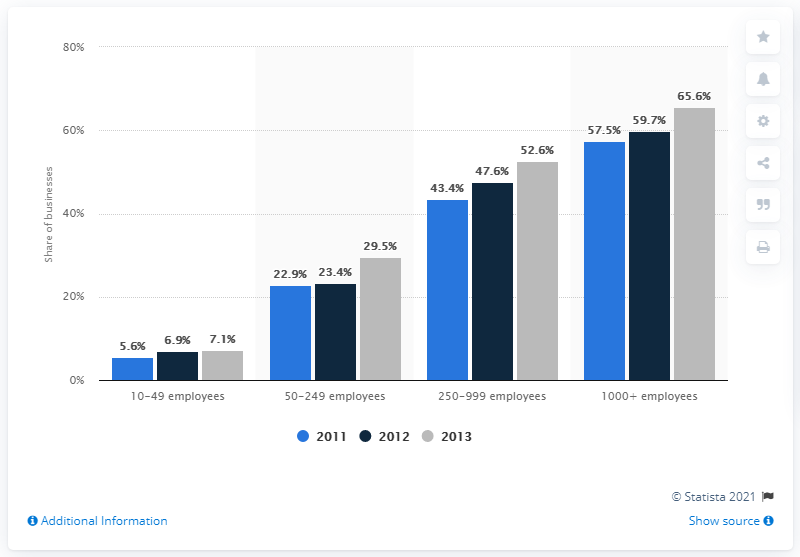Indicate a few pertinent items in this graphic. In 2013, the color grey is associated with a particular year. In 2013, 65.6% of businesses with over 1000 employees used ERP software. In the year 2011, the maximum number of employees was 57.5. 